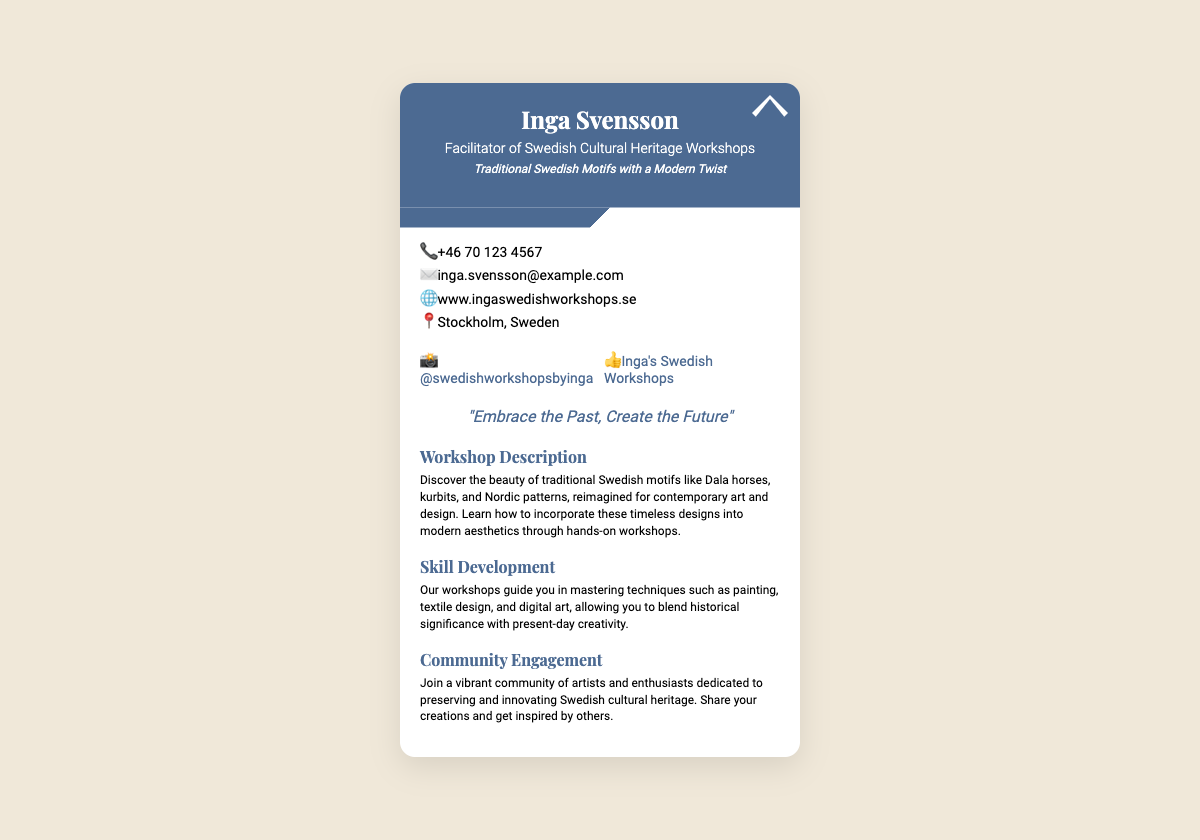what is the facilitator's name? The facilitator's name, prominently displayed in the document, is Inga Svensson.
Answer: Inga Svensson what is the tagline of the workshops? The tagline is provided directly under the facilitator's title and describes the theme of the workshops.
Answer: Traditional Swedish Motifs with a Modern Twist what is the contact phone number? The contact information includes a phone number specified with a phone emoji.
Answer: +46 70 123 4567 what city are the workshops located in? The document specifies the location of the workshops clearly under the contact information section.
Answer: Stockholm, Sweden how many types of skill development are mentioned? There are three areas of skill development mentioned in the document as separate headings.
Answer: Three what is the motto stated on the business card? The motto is a phrase expressing the philosophy of the workshops and is found towards the bottom of the content.
Answer: "Embrace the Past, Create the Future" what is the focus of the workshop description? The workshop description highlights traditional Swedish motifs and their incorporation into modern aesthetics.
Answer: Traditional Swedish motifs name one social media link listed on the card. The document provides a few social media handles for connecting with the workshops.
Answer: @swedishworkshopsbyinga how does the card visually represent Swedish culture? The presence of a Dala horse styled graphic indicates a connection to traditional Swedish culture.
Answer: Dala horse 